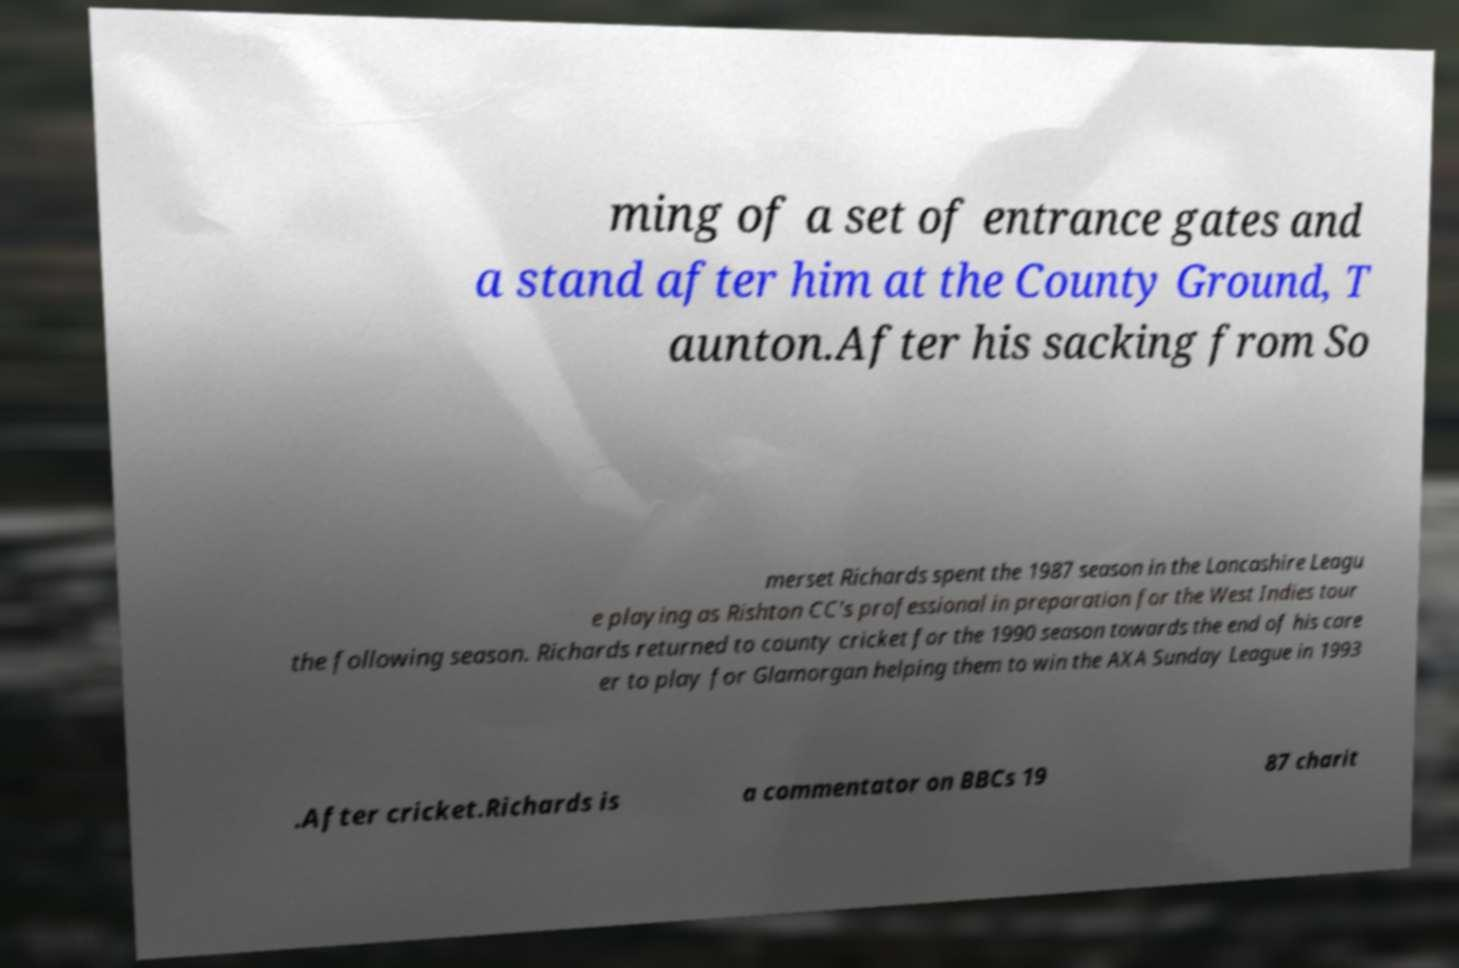What messages or text are displayed in this image? I need them in a readable, typed format. ming of a set of entrance gates and a stand after him at the County Ground, T aunton.After his sacking from So merset Richards spent the 1987 season in the Lancashire Leagu e playing as Rishton CC's professional in preparation for the West Indies tour the following season. Richards returned to county cricket for the 1990 season towards the end of his care er to play for Glamorgan helping them to win the AXA Sunday League in 1993 .After cricket.Richards is a commentator on BBCs 19 87 charit 